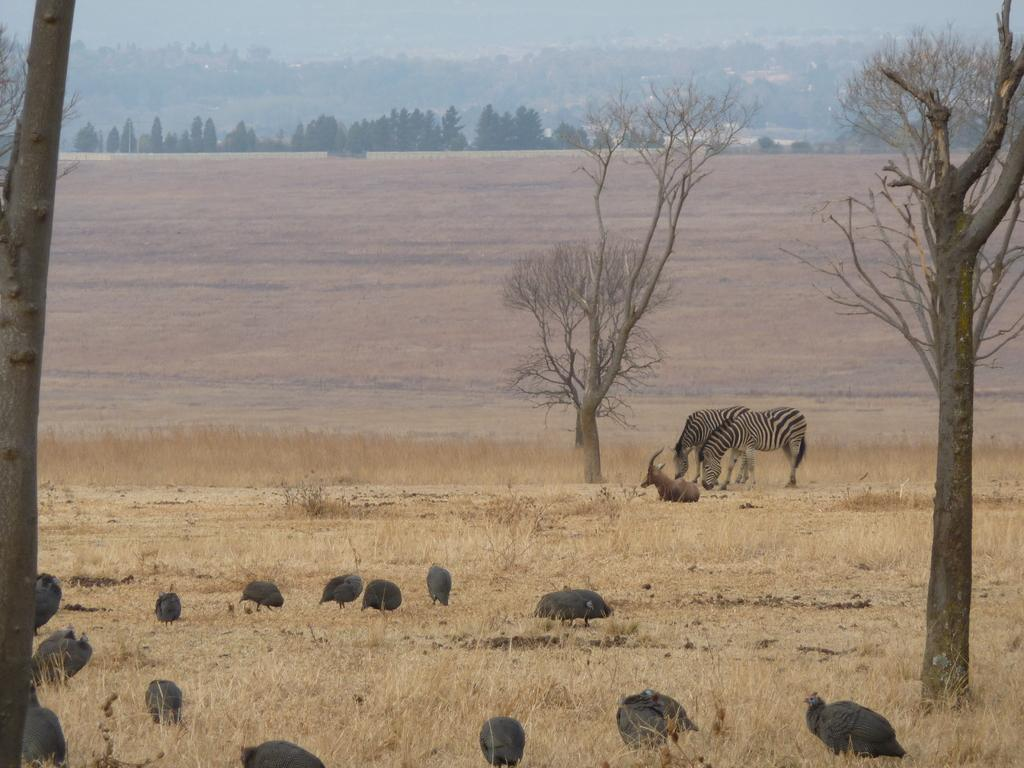What type of animals can be seen in the image? There are guinea fowl and zebras in the image. Can you describe the animal on the grass in the image? There is an animal on the grass in the image, but it is not specified which one. What can be seen at the top of the image? Trees are visible at the top of the image. What is the ground like in the image? The ground is visible in the image. What type of needle can be seen in the image? There is no needle present in the image. How many sticks are visible in the image? There are no sticks visible in the image. 